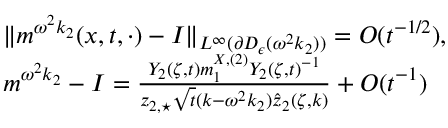<formula> <loc_0><loc_0><loc_500><loc_500>\begin{array} { r l } & { \| m ^ { \omega ^ { 2 } k _ { 2 } } ( x , t , \cdot ) - I \| _ { L ^ { \infty } ( \partial D _ { \epsilon } ( \omega ^ { 2 } k _ { 2 } ) ) } = O ( t ^ { - 1 / 2 } ) , } \\ & { m ^ { \omega ^ { 2 } k _ { 2 } } - I = \frac { Y _ { 2 } ( \zeta , t ) m _ { 1 } ^ { X , ( 2 ) } Y _ { 2 } ( \zeta , t ) ^ { - 1 } } { z _ { 2 , ^ { * } } \sqrt { t } ( k - \omega ^ { 2 } k _ { 2 } ) \hat { z } _ { 2 } ( \zeta , k ) } + O ( t ^ { - 1 } ) } \end{array}</formula> 